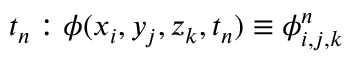Convert formula to latex. <formula><loc_0><loc_0><loc_500><loc_500>t _ { n } \colon \phi ( x _ { i } , y _ { j } , z _ { k } , t _ { n } ) \equiv \phi _ { i , j , k } ^ { n }</formula> 